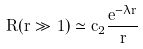Convert formula to latex. <formula><loc_0><loc_0><loc_500><loc_500>R ( r \gg 1 ) \simeq c _ { 2 } \frac { e ^ { - \lambda r } } { r }</formula> 